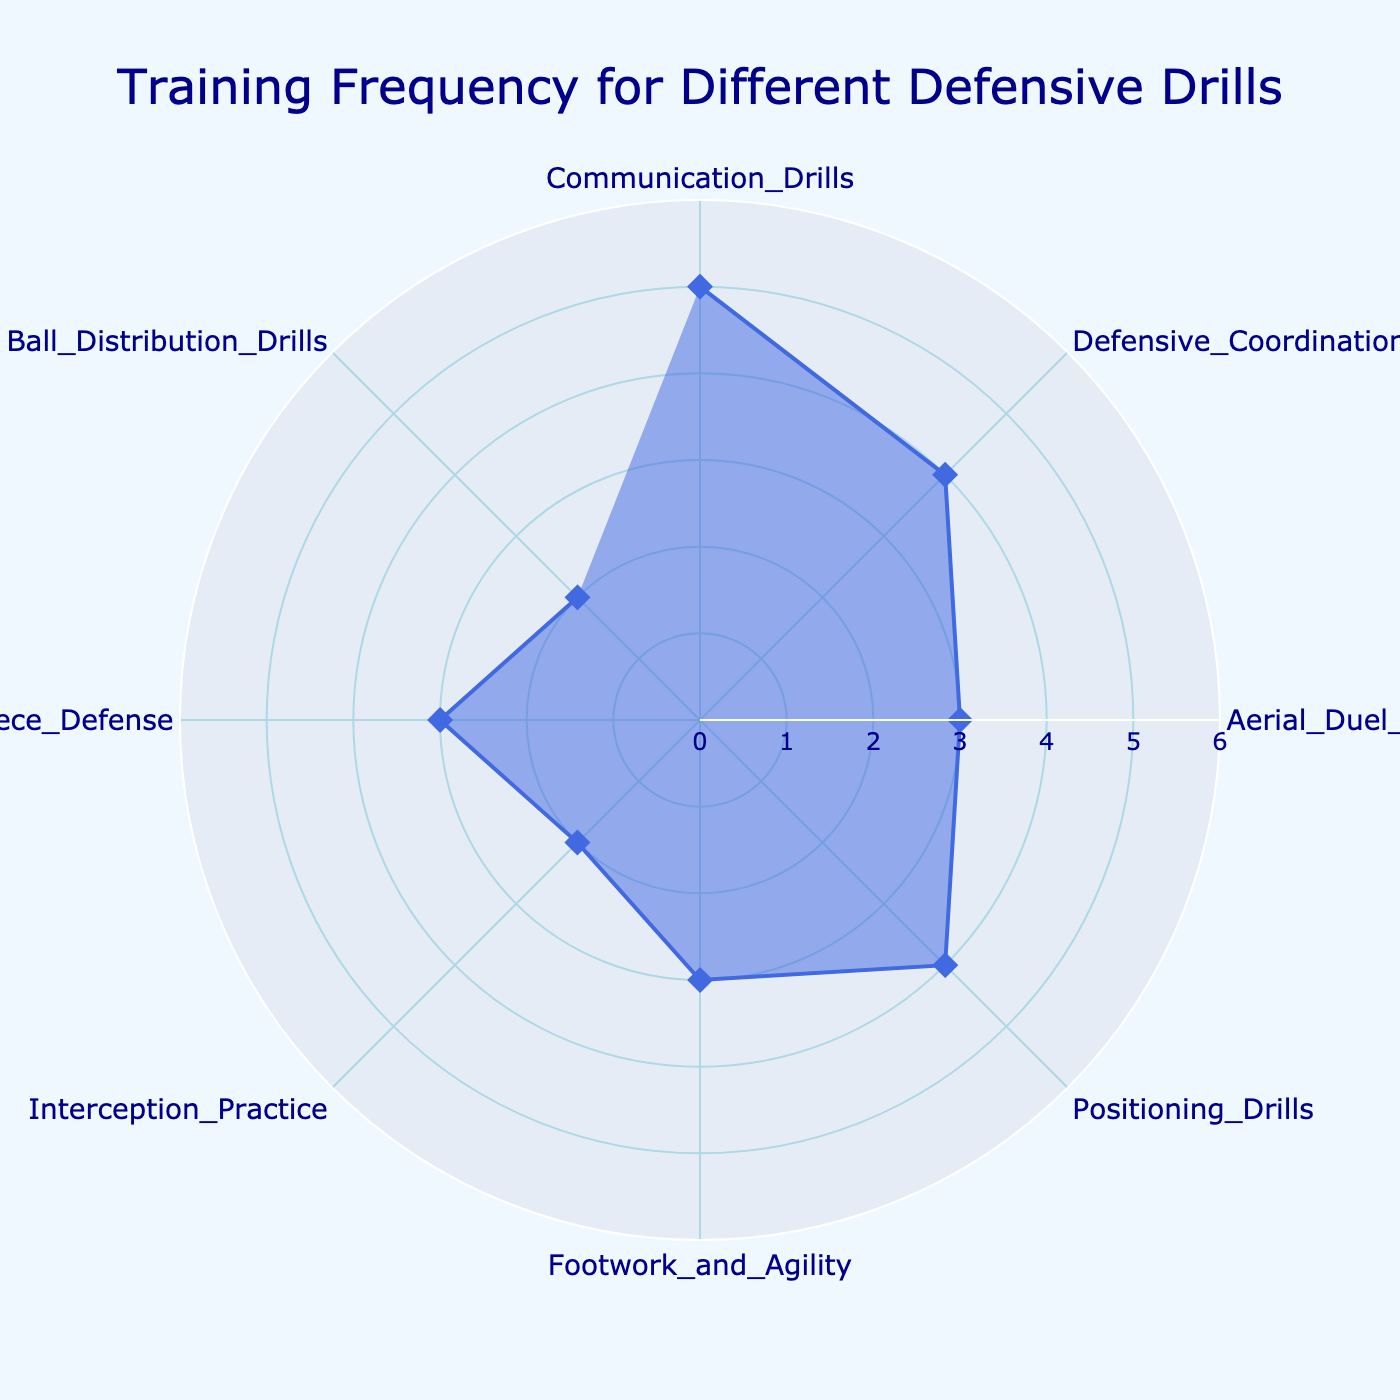What is the title of the radar chart? The title of the radar chart is located at the top center of the figure.
Answer: Training Frequency for Different Defensive Drills How many defensive drills are listed in the radar chart? Counting each distinct label around the polar axis gives the number of defensive drills displayed.
Answer: Eight Which defensive drill has the highest training frequency per week? By looking at the values around the radar chart, we find that the highest peak corresponds to the 'Communication Drills'.
Answer: Communication Drills Which defensive drills are practiced 3 times per week? Finding the points where the value equals 3 and checking their labels reveals practiced drills.
Answer: Aerial Duel Practice, Footwork and Agility, Set Piece Defense What is the average training frequency for all the drills combined? Sum the frequencies (5 + 4 + 3 + 4 + 3 + 2 + 3 + 2 = 26) and divide by the number of drills (8), 26/8 = 3.25.
Answer: 3.25 What is the difference in training frequency between the most and least practiced drills? Subtract the frequency of the least practiced drills (2) from the most practiced drill (5).
Answer: 3 Are any drills practiced less than 3 times per week? Checking the frequencies and noting those less than 3 identifies these drills.
Answer: Interception Practice, Ball Distribution Drills Which drills have the same training frequency and what is it? Finding drills with identical frequencies by visual inspection shows common values.
Answer: Defensive Coordination and Positioning Drills (4 times per week) Which drill would you suggest increasing if you want to balance training frequencies better? The drill with the lowest frequency, which stands out by comparison with others, should be considered.
Answer: Interception Practice or Ball Distribution Drills How does 'Defensive Coordination' training frequency compare to 'Footwork and Agility'? By looking at their respective values on the radar chart, we compare the frequencies.
Answer: Defensive Coordination is practiced 4 times per week, which is more than Footwork and Agility practiced 3 times per week 